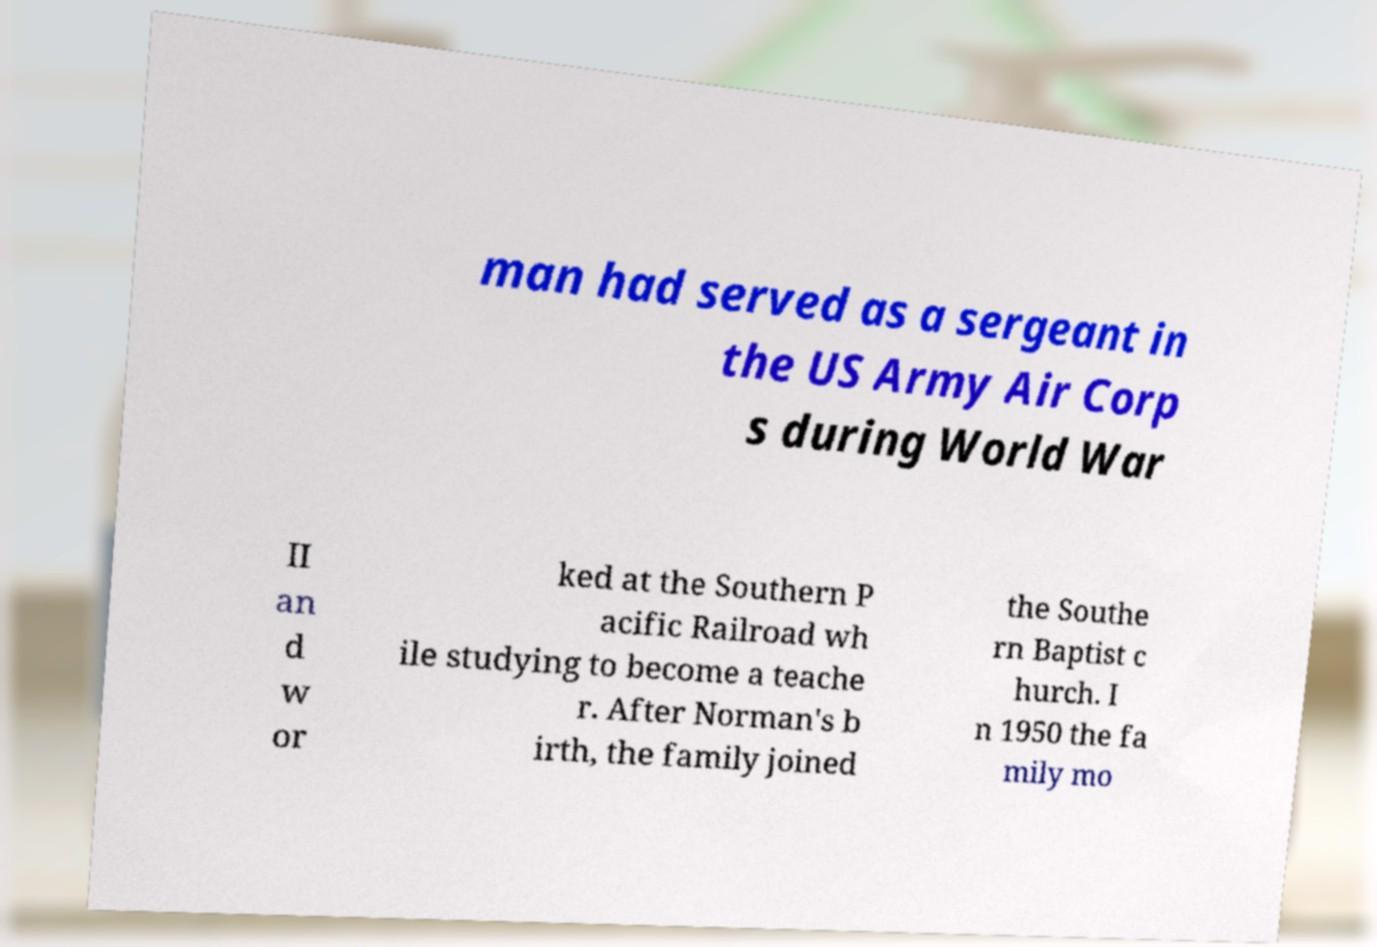There's text embedded in this image that I need extracted. Can you transcribe it verbatim? man had served as a sergeant in the US Army Air Corp s during World War II an d w or ked at the Southern P acific Railroad wh ile studying to become a teache r. After Norman's b irth, the family joined the Southe rn Baptist c hurch. I n 1950 the fa mily mo 